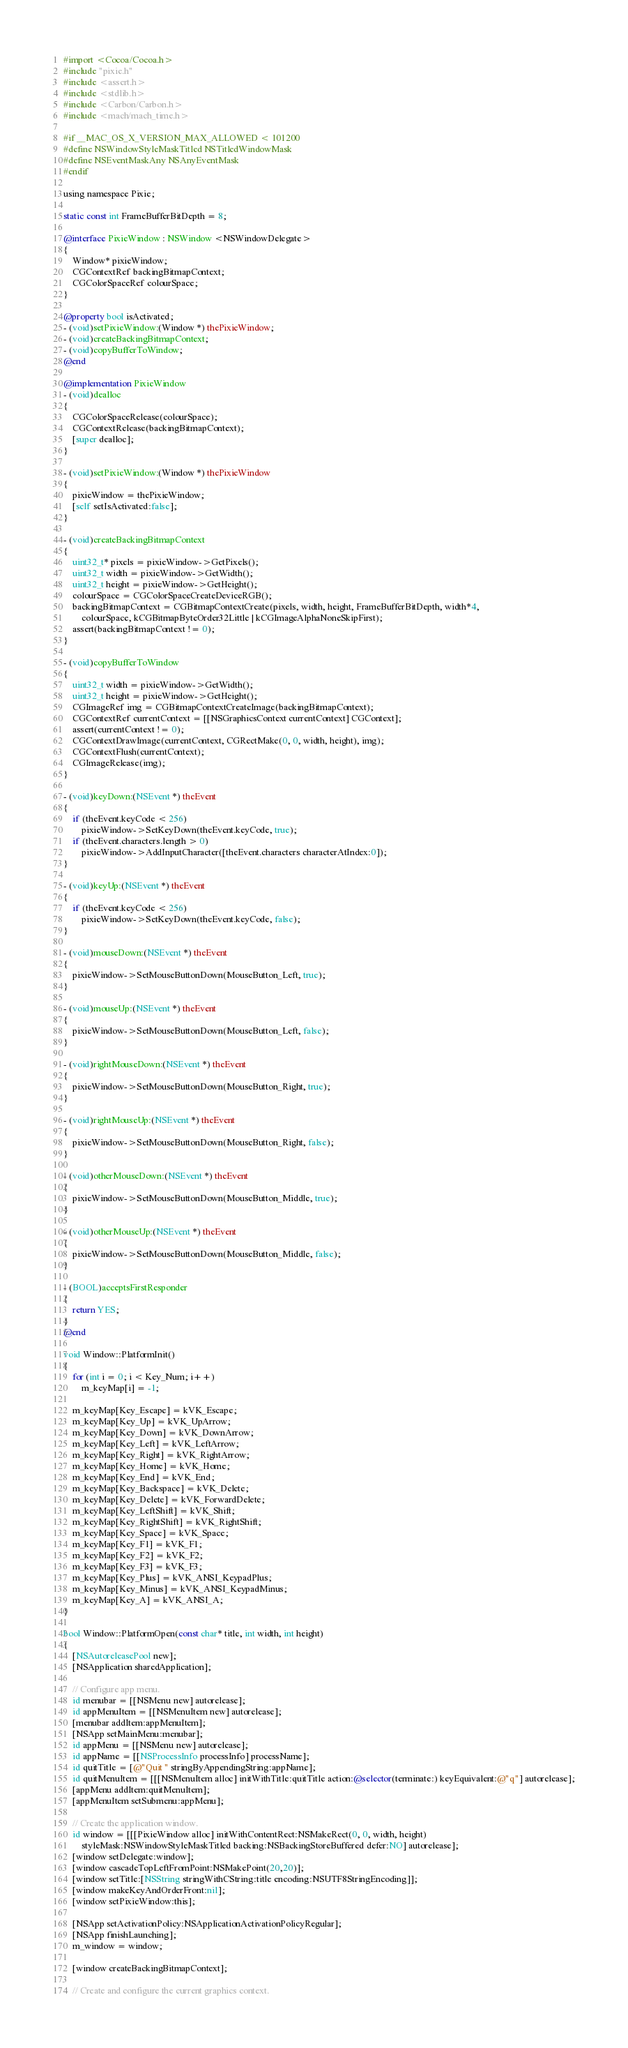Convert code to text. <code><loc_0><loc_0><loc_500><loc_500><_ObjectiveC_>#import <Cocoa/Cocoa.h>
#include "pixie.h"
#include <assert.h>
#include <stdlib.h>
#include <Carbon/Carbon.h>
#include <mach/mach_time.h>

#if __MAC_OS_X_VERSION_MAX_ALLOWED < 101200
#define NSWindowStyleMaskTitled NSTitledWindowMask
#define NSEventMaskAny NSAnyEventMask
#endif

using namespace Pixie;

static const int FrameBufferBitDepth = 8;

@interface PixieWindow : NSWindow <NSWindowDelegate>
{
    Window* pixieWindow;
    CGContextRef backingBitmapContext;
    CGColorSpaceRef colourSpace;
}

@property bool isActivated;
- (void)setPixieWindow:(Window *) thePixieWindow;
- (void)createBackingBitmapContext;
- (void)copyBufferToWindow;
@end

@implementation PixieWindow
- (void)dealloc
{
    CGColorSpaceRelease(colourSpace);
    CGContextRelease(backingBitmapContext);
    [super dealloc];
}

- (void)setPixieWindow:(Window *) thePixieWindow
{
    pixieWindow = thePixieWindow;
    [self setIsActivated:false];
}

- (void)createBackingBitmapContext
{
    uint32_t* pixels = pixieWindow->GetPixels();
    uint32_t width = pixieWindow->GetWidth();
    uint32_t height = pixieWindow->GetHeight();
    colourSpace = CGColorSpaceCreateDeviceRGB();
    backingBitmapContext = CGBitmapContextCreate(pixels, width, height, FrameBufferBitDepth, width*4,
        colourSpace, kCGBitmapByteOrder32Little | kCGImageAlphaNoneSkipFirst);
    assert(backingBitmapContext != 0);
}

- (void)copyBufferToWindow
{
    uint32_t width = pixieWindow->GetWidth();
    uint32_t height = pixieWindow->GetHeight();
    CGImageRef img = CGBitmapContextCreateImage(backingBitmapContext);
    CGContextRef currentContext = [[NSGraphicsContext currentContext] CGContext];
    assert(currentContext != 0);
    CGContextDrawImage(currentContext, CGRectMake(0, 0, width, height), img);
    CGContextFlush(currentContext);
    CGImageRelease(img);
}

- (void)keyDown:(NSEvent *) theEvent
{
    if (theEvent.keyCode < 256)
        pixieWindow->SetKeyDown(theEvent.keyCode, true);
    if (theEvent.characters.length > 0)
        pixieWindow->AddInputCharacter([theEvent.characters characterAtIndex:0]);
}

- (void)keyUp:(NSEvent *) theEvent
{
    if (theEvent.keyCode < 256)
        pixieWindow->SetKeyDown(theEvent.keyCode, false);
}

- (void)mouseDown:(NSEvent *) theEvent
{
    pixieWindow->SetMouseButtonDown(MouseButton_Left, true);
}

- (void)mouseUp:(NSEvent *) theEvent
{
    pixieWindow->SetMouseButtonDown(MouseButton_Left, false);
}

- (void)rightMouseDown:(NSEvent *) theEvent
{
    pixieWindow->SetMouseButtonDown(MouseButton_Right, true);
}

- (void)rightMouseUp:(NSEvent *) theEvent
{
    pixieWindow->SetMouseButtonDown(MouseButton_Right, false);
}

- (void)otherMouseDown:(NSEvent *) theEvent
{
    pixieWindow->SetMouseButtonDown(MouseButton_Middle, true);
}

- (void)otherMouseUp:(NSEvent *) theEvent
{
    pixieWindow->SetMouseButtonDown(MouseButton_Middle, false);
}

- (BOOL)acceptsFirstResponder
{
    return YES;
}
@end

void Window::PlatformInit()
{
    for (int i = 0; i < Key_Num; i++)
        m_keyMap[i] = -1;

    m_keyMap[Key_Escape] = kVK_Escape;
    m_keyMap[Key_Up] = kVK_UpArrow;
    m_keyMap[Key_Down] = kVK_DownArrow;
    m_keyMap[Key_Left] = kVK_LeftArrow;
    m_keyMap[Key_Right] = kVK_RightArrow;
    m_keyMap[Key_Home] = kVK_Home;
    m_keyMap[Key_End] = kVK_End;
    m_keyMap[Key_Backspace] = kVK_Delete;
    m_keyMap[Key_Delete] = kVK_ForwardDelete;
    m_keyMap[Key_LeftShift] = kVK_Shift;
    m_keyMap[Key_RightShift] = kVK_RightShift;
    m_keyMap[Key_Space] = kVK_Space;
    m_keyMap[Key_F1] = kVK_F1;
    m_keyMap[Key_F2] = kVK_F2;
    m_keyMap[Key_F3] = kVK_F3;
    m_keyMap[Key_Plus] = kVK_ANSI_KeypadPlus;
    m_keyMap[Key_Minus] = kVK_ANSI_KeypadMinus;
    m_keyMap[Key_A] = kVK_ANSI_A;
}

bool Window::PlatformOpen(const char* title, int width, int height)
{
    [NSAutoreleasePool new];
    [NSApplication sharedApplication];

    // Configure app menu.
    id menubar = [[NSMenu new] autorelease];
    id appMenuItem = [[NSMenuItem new] autorelease];
    [menubar addItem:appMenuItem];
    [NSApp setMainMenu:menubar];
    id appMenu = [[NSMenu new] autorelease];
    id appName = [[NSProcessInfo processInfo] processName];
    id quitTitle = [@"Quit " stringByAppendingString:appName];
    id quitMenuItem = [[[NSMenuItem alloc] initWithTitle:quitTitle action:@selector(terminate:) keyEquivalent:@"q"] autorelease];
    [appMenu addItem:quitMenuItem];
    [appMenuItem setSubmenu:appMenu];

    // Create the application window.
    id window = [[[PixieWindow alloc] initWithContentRect:NSMakeRect(0, 0, width, height)
        styleMask:NSWindowStyleMaskTitled backing:NSBackingStoreBuffered defer:NO] autorelease];
    [window setDelegate:window];
    [window cascadeTopLeftFromPoint:NSMakePoint(20,20)];
    [window setTitle:[NSString stringWithCString:title encoding:NSUTF8StringEncoding]];
    [window makeKeyAndOrderFront:nil];
    [window setPixieWindow:this];

    [NSApp setActivationPolicy:NSApplicationActivationPolicyRegular];
    [NSApp finishLaunching];
    m_window = window;

    [window createBackingBitmapContext];

    // Create and configure the current graphics context.</code> 